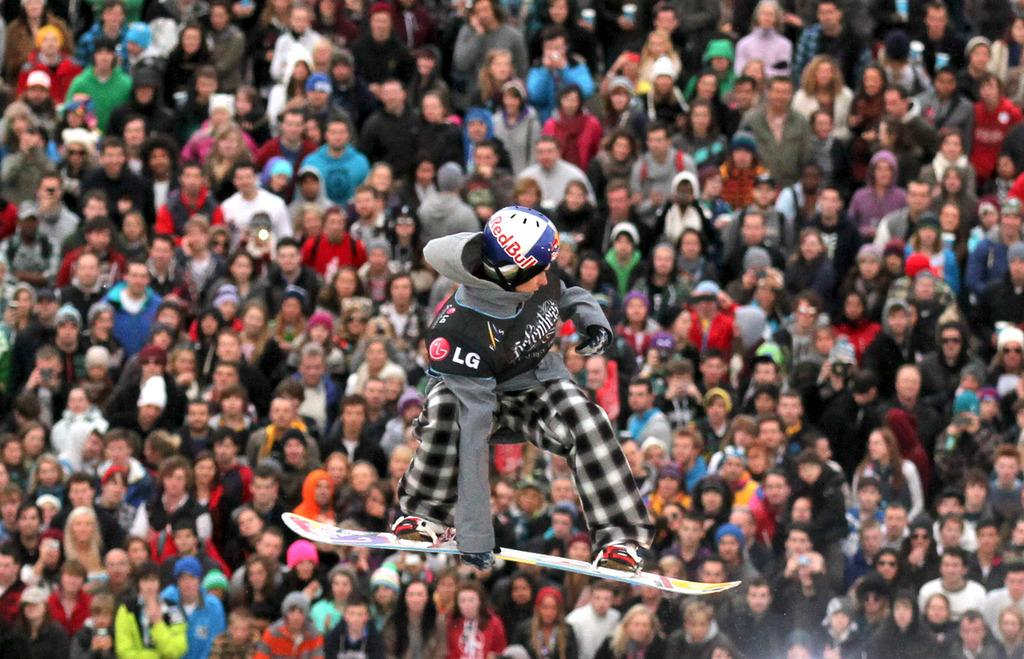What is the person in the image doing? The person in the image is standing on a skateboard. What type of headwear is the person wearing? The person is wearing a cap. What type of clothing is the person wearing? The person is wearing a hoodie. Can you describe the setting in the image? There are many people present at the back. What invention is the person using to balance on the skateboard? The person is not using any invention to balance on the skateboard; they are simply standing on it. How many quivers can be seen on the person in the image? There are no quivers present on the person in the image. 